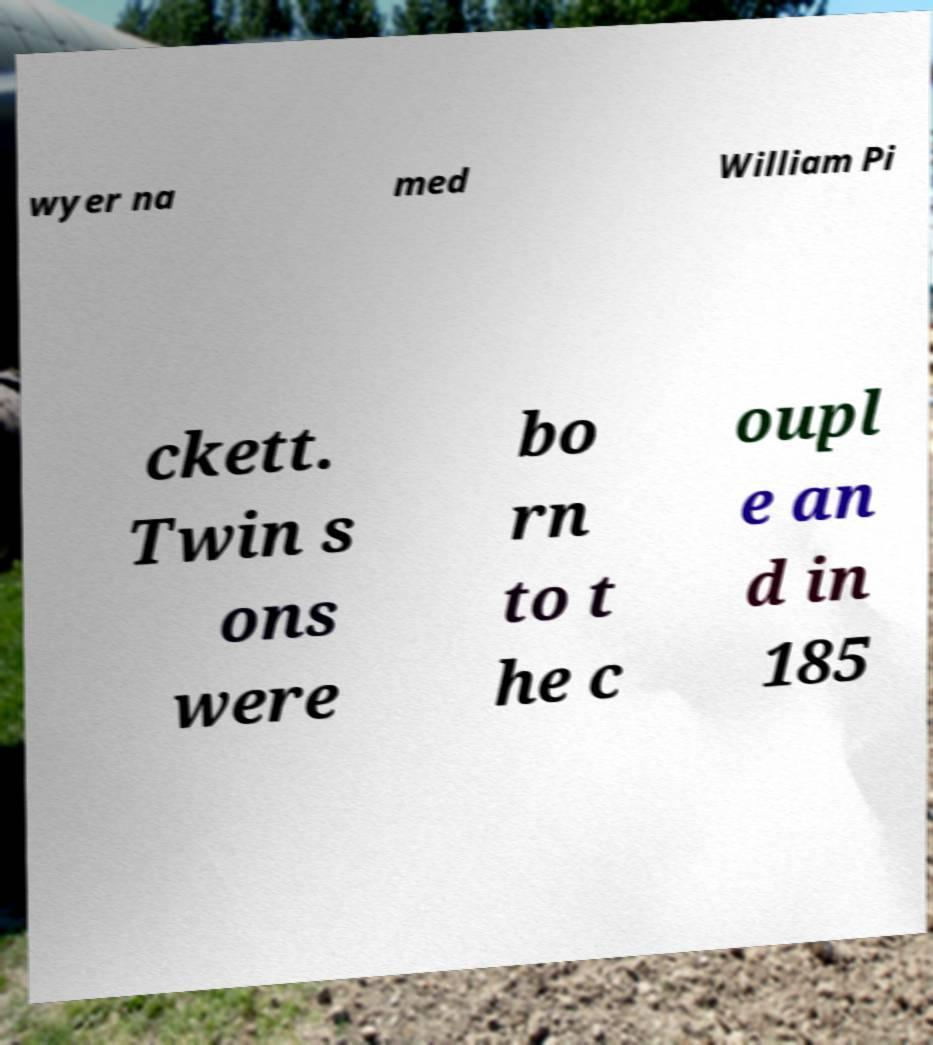Please read and relay the text visible in this image. What does it say? wyer na med William Pi ckett. Twin s ons were bo rn to t he c oupl e an d in 185 